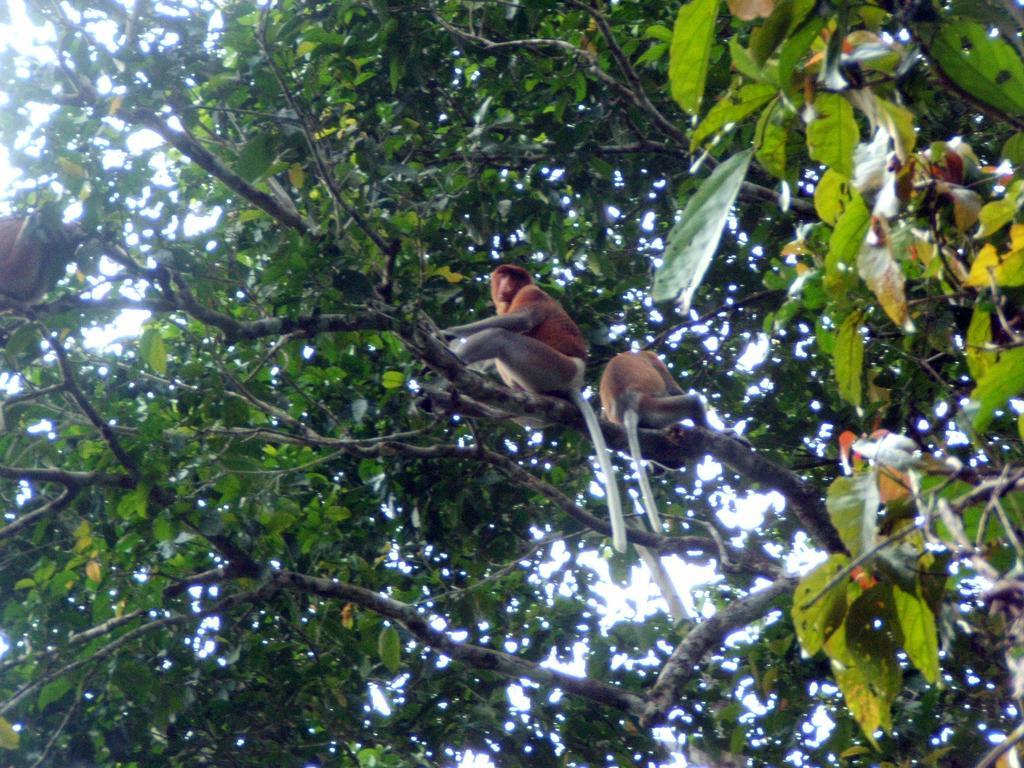In one or two sentences, can you explain what this image depicts? As we can see in the image, there is a tree. On tree there are two monkeys. These monkeys are in brown color and tails are in white color. 